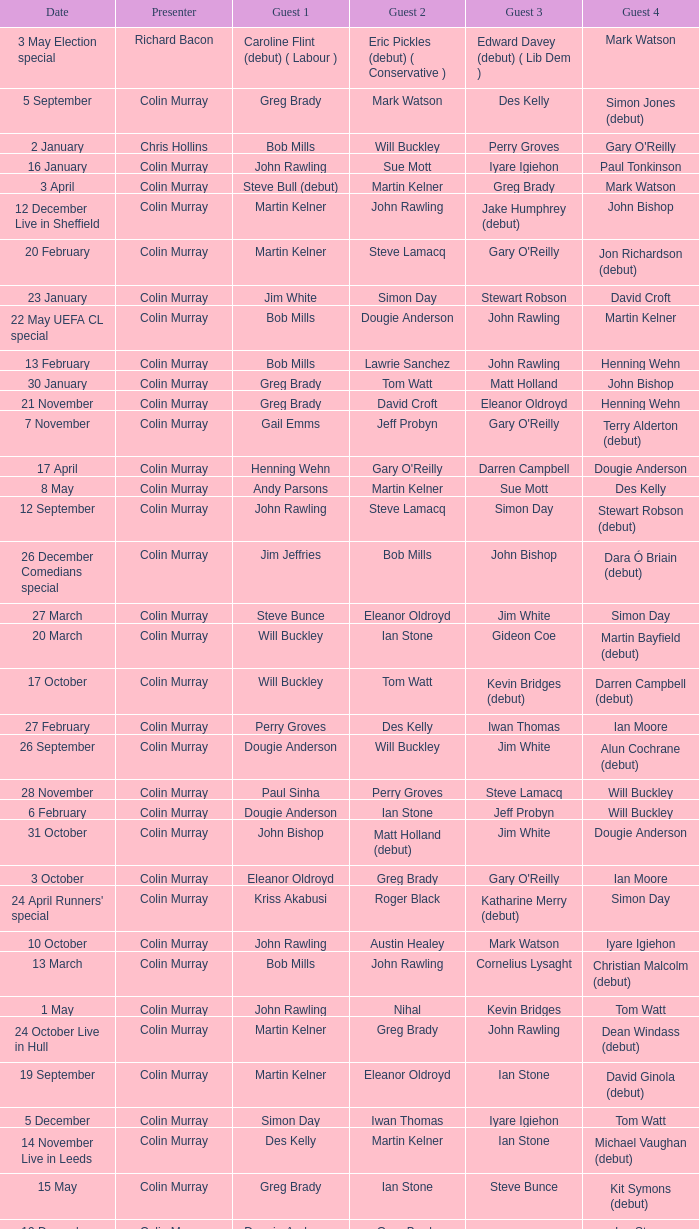How many people are guest 1 on episodes where guest 4 is Des Kelly? 1.0. 